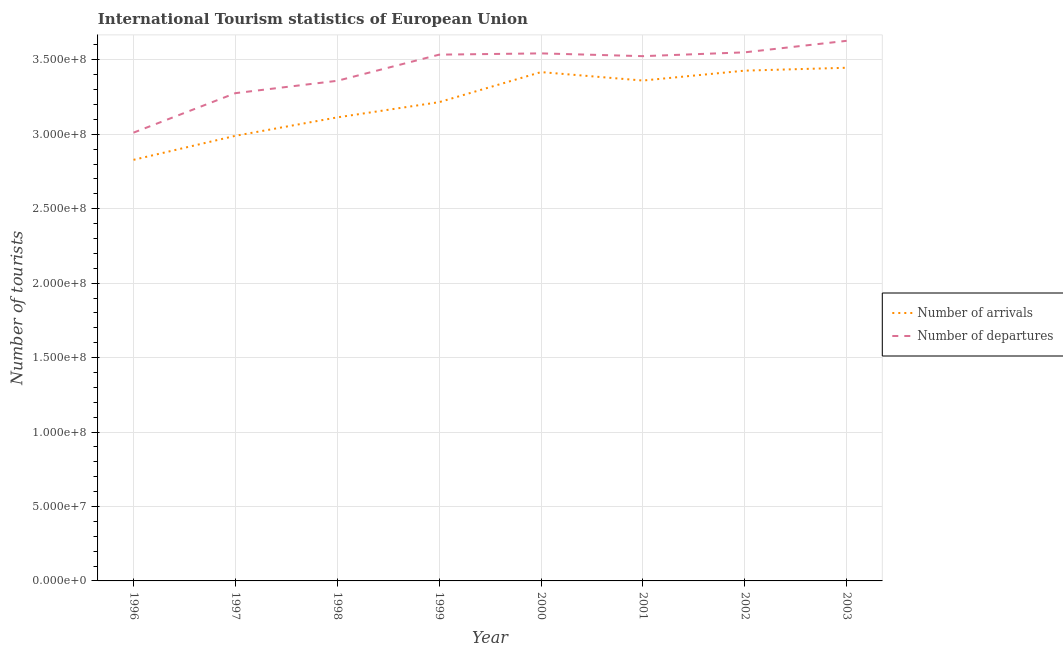Is the number of lines equal to the number of legend labels?
Give a very brief answer. Yes. What is the number of tourist arrivals in 2003?
Provide a succinct answer. 3.45e+08. Across all years, what is the maximum number of tourist departures?
Give a very brief answer. 3.63e+08. Across all years, what is the minimum number of tourist departures?
Provide a short and direct response. 3.01e+08. What is the total number of tourist departures in the graph?
Keep it short and to the point. 2.74e+09. What is the difference between the number of tourist arrivals in 1998 and that in 2000?
Offer a very short reply. -3.04e+07. What is the difference between the number of tourist arrivals in 1997 and the number of tourist departures in 2001?
Make the answer very short. -5.35e+07. What is the average number of tourist arrivals per year?
Provide a short and direct response. 3.22e+08. In the year 1996, what is the difference between the number of tourist departures and number of tourist arrivals?
Make the answer very short. 1.83e+07. In how many years, is the number of tourist arrivals greater than 230000000?
Your response must be concise. 8. What is the ratio of the number of tourist arrivals in 1998 to that in 2003?
Your answer should be very brief. 0.9. What is the difference between the highest and the second highest number of tourist arrivals?
Keep it short and to the point. 1.93e+06. What is the difference between the highest and the lowest number of tourist departures?
Your response must be concise. 6.17e+07. In how many years, is the number of tourist arrivals greater than the average number of tourist arrivals taken over all years?
Your answer should be compact. 4. Does the number of tourist arrivals monotonically increase over the years?
Keep it short and to the point. No. Is the number of tourist departures strictly less than the number of tourist arrivals over the years?
Keep it short and to the point. No. Does the graph contain any zero values?
Provide a short and direct response. No. Does the graph contain grids?
Give a very brief answer. Yes. What is the title of the graph?
Offer a terse response. International Tourism statistics of European Union. What is the label or title of the X-axis?
Your answer should be very brief. Year. What is the label or title of the Y-axis?
Give a very brief answer. Number of tourists. What is the Number of tourists in Number of arrivals in 1996?
Make the answer very short. 2.83e+08. What is the Number of tourists in Number of departures in 1996?
Your response must be concise. 3.01e+08. What is the Number of tourists in Number of arrivals in 1997?
Ensure brevity in your answer.  2.99e+08. What is the Number of tourists of Number of departures in 1997?
Provide a short and direct response. 3.28e+08. What is the Number of tourists in Number of arrivals in 1998?
Your response must be concise. 3.11e+08. What is the Number of tourists in Number of departures in 1998?
Keep it short and to the point. 3.36e+08. What is the Number of tourists of Number of arrivals in 1999?
Provide a short and direct response. 3.22e+08. What is the Number of tourists of Number of departures in 1999?
Keep it short and to the point. 3.53e+08. What is the Number of tourists of Number of arrivals in 2000?
Offer a very short reply. 3.42e+08. What is the Number of tourists in Number of departures in 2000?
Provide a succinct answer. 3.54e+08. What is the Number of tourists in Number of arrivals in 2001?
Ensure brevity in your answer.  3.36e+08. What is the Number of tourists of Number of departures in 2001?
Provide a short and direct response. 3.52e+08. What is the Number of tourists in Number of arrivals in 2002?
Make the answer very short. 3.43e+08. What is the Number of tourists in Number of departures in 2002?
Ensure brevity in your answer.  3.55e+08. What is the Number of tourists of Number of arrivals in 2003?
Make the answer very short. 3.45e+08. What is the Number of tourists of Number of departures in 2003?
Provide a short and direct response. 3.63e+08. Across all years, what is the maximum Number of tourists of Number of arrivals?
Provide a short and direct response. 3.45e+08. Across all years, what is the maximum Number of tourists of Number of departures?
Provide a short and direct response. 3.63e+08. Across all years, what is the minimum Number of tourists of Number of arrivals?
Give a very brief answer. 2.83e+08. Across all years, what is the minimum Number of tourists in Number of departures?
Give a very brief answer. 3.01e+08. What is the total Number of tourists in Number of arrivals in the graph?
Ensure brevity in your answer.  2.58e+09. What is the total Number of tourists in Number of departures in the graph?
Offer a very short reply. 2.74e+09. What is the difference between the Number of tourists in Number of arrivals in 1996 and that in 1997?
Offer a terse response. -1.61e+07. What is the difference between the Number of tourists of Number of departures in 1996 and that in 1997?
Offer a terse response. -2.65e+07. What is the difference between the Number of tourists in Number of arrivals in 1996 and that in 1998?
Provide a succinct answer. -2.85e+07. What is the difference between the Number of tourists of Number of departures in 1996 and that in 1998?
Offer a terse response. -3.48e+07. What is the difference between the Number of tourists in Number of arrivals in 1996 and that in 1999?
Offer a very short reply. -3.87e+07. What is the difference between the Number of tourists in Number of departures in 1996 and that in 1999?
Keep it short and to the point. -5.24e+07. What is the difference between the Number of tourists in Number of arrivals in 1996 and that in 2000?
Make the answer very short. -5.89e+07. What is the difference between the Number of tourists of Number of departures in 1996 and that in 2000?
Your response must be concise. -5.32e+07. What is the difference between the Number of tourists of Number of arrivals in 1996 and that in 2001?
Provide a short and direct response. -5.32e+07. What is the difference between the Number of tourists in Number of departures in 1996 and that in 2001?
Your answer should be very brief. -5.14e+07. What is the difference between the Number of tourists in Number of arrivals in 1996 and that in 2002?
Provide a succinct answer. -5.99e+07. What is the difference between the Number of tourists of Number of departures in 1996 and that in 2002?
Your response must be concise. -5.39e+07. What is the difference between the Number of tourists of Number of arrivals in 1996 and that in 2003?
Make the answer very short. -6.18e+07. What is the difference between the Number of tourists in Number of departures in 1996 and that in 2003?
Your answer should be compact. -6.17e+07. What is the difference between the Number of tourists of Number of arrivals in 1997 and that in 1998?
Make the answer very short. -1.24e+07. What is the difference between the Number of tourists of Number of departures in 1997 and that in 1998?
Your answer should be very brief. -8.30e+06. What is the difference between the Number of tourists of Number of arrivals in 1997 and that in 1999?
Offer a terse response. -2.26e+07. What is the difference between the Number of tourists in Number of departures in 1997 and that in 1999?
Your answer should be very brief. -2.59e+07. What is the difference between the Number of tourists of Number of arrivals in 1997 and that in 2000?
Ensure brevity in your answer.  -4.28e+07. What is the difference between the Number of tourists in Number of departures in 1997 and that in 2000?
Offer a very short reply. -2.67e+07. What is the difference between the Number of tourists in Number of arrivals in 1997 and that in 2001?
Your answer should be compact. -3.71e+07. What is the difference between the Number of tourists of Number of departures in 1997 and that in 2001?
Your response must be concise. -2.49e+07. What is the difference between the Number of tourists of Number of arrivals in 1997 and that in 2002?
Your response must be concise. -4.38e+07. What is the difference between the Number of tourists of Number of departures in 1997 and that in 2002?
Your response must be concise. -2.74e+07. What is the difference between the Number of tourists of Number of arrivals in 1997 and that in 2003?
Make the answer very short. -4.57e+07. What is the difference between the Number of tourists of Number of departures in 1997 and that in 2003?
Your answer should be compact. -3.51e+07. What is the difference between the Number of tourists in Number of arrivals in 1998 and that in 1999?
Offer a terse response. -1.02e+07. What is the difference between the Number of tourists of Number of departures in 1998 and that in 1999?
Your answer should be very brief. -1.76e+07. What is the difference between the Number of tourists of Number of arrivals in 1998 and that in 2000?
Provide a short and direct response. -3.04e+07. What is the difference between the Number of tourists in Number of departures in 1998 and that in 2000?
Offer a terse response. -1.84e+07. What is the difference between the Number of tourists of Number of arrivals in 1998 and that in 2001?
Ensure brevity in your answer.  -2.47e+07. What is the difference between the Number of tourists in Number of departures in 1998 and that in 2001?
Offer a very short reply. -1.66e+07. What is the difference between the Number of tourists of Number of arrivals in 1998 and that in 2002?
Give a very brief answer. -3.14e+07. What is the difference between the Number of tourists in Number of departures in 1998 and that in 2002?
Give a very brief answer. -1.91e+07. What is the difference between the Number of tourists of Number of arrivals in 1998 and that in 2003?
Give a very brief answer. -3.33e+07. What is the difference between the Number of tourists in Number of departures in 1998 and that in 2003?
Offer a terse response. -2.68e+07. What is the difference between the Number of tourists of Number of arrivals in 1999 and that in 2000?
Offer a very short reply. -2.02e+07. What is the difference between the Number of tourists in Number of departures in 1999 and that in 2000?
Your response must be concise. -8.54e+05. What is the difference between the Number of tourists of Number of arrivals in 1999 and that in 2001?
Your response must be concise. -1.45e+07. What is the difference between the Number of tourists in Number of departures in 1999 and that in 2001?
Your answer should be very brief. 1.01e+06. What is the difference between the Number of tourists in Number of arrivals in 1999 and that in 2002?
Provide a short and direct response. -2.12e+07. What is the difference between the Number of tourists in Number of departures in 1999 and that in 2002?
Make the answer very short. -1.55e+06. What is the difference between the Number of tourists in Number of arrivals in 1999 and that in 2003?
Your answer should be very brief. -2.31e+07. What is the difference between the Number of tourists of Number of departures in 1999 and that in 2003?
Your answer should be very brief. -9.29e+06. What is the difference between the Number of tourists in Number of arrivals in 2000 and that in 2001?
Make the answer very short. 5.67e+06. What is the difference between the Number of tourists of Number of departures in 2000 and that in 2001?
Ensure brevity in your answer.  1.86e+06. What is the difference between the Number of tourists in Number of arrivals in 2000 and that in 2002?
Keep it short and to the point. -9.82e+05. What is the difference between the Number of tourists in Number of departures in 2000 and that in 2002?
Offer a very short reply. -7.01e+05. What is the difference between the Number of tourists in Number of arrivals in 2000 and that in 2003?
Your response must be concise. -2.91e+06. What is the difference between the Number of tourists of Number of departures in 2000 and that in 2003?
Ensure brevity in your answer.  -8.43e+06. What is the difference between the Number of tourists in Number of arrivals in 2001 and that in 2002?
Provide a short and direct response. -6.65e+06. What is the difference between the Number of tourists of Number of departures in 2001 and that in 2002?
Your response must be concise. -2.56e+06. What is the difference between the Number of tourists in Number of arrivals in 2001 and that in 2003?
Your answer should be very brief. -8.59e+06. What is the difference between the Number of tourists of Number of departures in 2001 and that in 2003?
Your response must be concise. -1.03e+07. What is the difference between the Number of tourists of Number of arrivals in 2002 and that in 2003?
Your response must be concise. -1.93e+06. What is the difference between the Number of tourists in Number of departures in 2002 and that in 2003?
Your response must be concise. -7.73e+06. What is the difference between the Number of tourists in Number of arrivals in 1996 and the Number of tourists in Number of departures in 1997?
Ensure brevity in your answer.  -4.48e+07. What is the difference between the Number of tourists of Number of arrivals in 1996 and the Number of tourists of Number of departures in 1998?
Ensure brevity in your answer.  -5.31e+07. What is the difference between the Number of tourists of Number of arrivals in 1996 and the Number of tourists of Number of departures in 1999?
Provide a short and direct response. -7.06e+07. What is the difference between the Number of tourists in Number of arrivals in 1996 and the Number of tourists in Number of departures in 2000?
Provide a short and direct response. -7.15e+07. What is the difference between the Number of tourists of Number of arrivals in 1996 and the Number of tourists of Number of departures in 2001?
Offer a terse response. -6.96e+07. What is the difference between the Number of tourists in Number of arrivals in 1996 and the Number of tourists in Number of departures in 2002?
Provide a short and direct response. -7.22e+07. What is the difference between the Number of tourists in Number of arrivals in 1996 and the Number of tourists in Number of departures in 2003?
Ensure brevity in your answer.  -7.99e+07. What is the difference between the Number of tourists of Number of arrivals in 1997 and the Number of tourists of Number of departures in 1998?
Ensure brevity in your answer.  -3.69e+07. What is the difference between the Number of tourists in Number of arrivals in 1997 and the Number of tourists in Number of departures in 1999?
Provide a short and direct response. -5.45e+07. What is the difference between the Number of tourists of Number of arrivals in 1997 and the Number of tourists of Number of departures in 2000?
Ensure brevity in your answer.  -5.54e+07. What is the difference between the Number of tourists of Number of arrivals in 1997 and the Number of tourists of Number of departures in 2001?
Make the answer very short. -5.35e+07. What is the difference between the Number of tourists of Number of arrivals in 1997 and the Number of tourists of Number of departures in 2002?
Offer a terse response. -5.61e+07. What is the difference between the Number of tourists of Number of arrivals in 1997 and the Number of tourists of Number of departures in 2003?
Keep it short and to the point. -6.38e+07. What is the difference between the Number of tourists of Number of arrivals in 1998 and the Number of tourists of Number of departures in 1999?
Provide a succinct answer. -4.21e+07. What is the difference between the Number of tourists in Number of arrivals in 1998 and the Number of tourists in Number of departures in 2000?
Provide a succinct answer. -4.30e+07. What is the difference between the Number of tourists in Number of arrivals in 1998 and the Number of tourists in Number of departures in 2001?
Your answer should be very brief. -4.11e+07. What is the difference between the Number of tourists of Number of arrivals in 1998 and the Number of tourists of Number of departures in 2002?
Your response must be concise. -4.37e+07. What is the difference between the Number of tourists in Number of arrivals in 1998 and the Number of tourists in Number of departures in 2003?
Provide a succinct answer. -5.14e+07. What is the difference between the Number of tourists of Number of arrivals in 1999 and the Number of tourists of Number of departures in 2000?
Your response must be concise. -3.28e+07. What is the difference between the Number of tourists in Number of arrivals in 1999 and the Number of tourists in Number of departures in 2001?
Your answer should be compact. -3.09e+07. What is the difference between the Number of tourists in Number of arrivals in 1999 and the Number of tourists in Number of departures in 2002?
Make the answer very short. -3.35e+07. What is the difference between the Number of tourists in Number of arrivals in 1999 and the Number of tourists in Number of departures in 2003?
Make the answer very short. -4.12e+07. What is the difference between the Number of tourists of Number of arrivals in 2000 and the Number of tourists of Number of departures in 2001?
Make the answer very short. -1.07e+07. What is the difference between the Number of tourists in Number of arrivals in 2000 and the Number of tourists in Number of departures in 2002?
Provide a succinct answer. -1.33e+07. What is the difference between the Number of tourists of Number of arrivals in 2000 and the Number of tourists of Number of departures in 2003?
Make the answer very short. -2.10e+07. What is the difference between the Number of tourists of Number of arrivals in 2001 and the Number of tourists of Number of departures in 2002?
Provide a succinct answer. -1.89e+07. What is the difference between the Number of tourists of Number of arrivals in 2001 and the Number of tourists of Number of departures in 2003?
Ensure brevity in your answer.  -2.67e+07. What is the difference between the Number of tourists in Number of arrivals in 2002 and the Number of tourists in Number of departures in 2003?
Your response must be concise. -2.00e+07. What is the average Number of tourists of Number of arrivals per year?
Provide a short and direct response. 3.22e+08. What is the average Number of tourists in Number of departures per year?
Make the answer very short. 3.43e+08. In the year 1996, what is the difference between the Number of tourists of Number of arrivals and Number of tourists of Number of departures?
Your answer should be very brief. -1.83e+07. In the year 1997, what is the difference between the Number of tourists of Number of arrivals and Number of tourists of Number of departures?
Offer a terse response. -2.86e+07. In the year 1998, what is the difference between the Number of tourists in Number of arrivals and Number of tourists in Number of departures?
Your response must be concise. -2.46e+07. In the year 1999, what is the difference between the Number of tourists in Number of arrivals and Number of tourists in Number of departures?
Your answer should be very brief. -3.19e+07. In the year 2000, what is the difference between the Number of tourists in Number of arrivals and Number of tourists in Number of departures?
Offer a terse response. -1.26e+07. In the year 2001, what is the difference between the Number of tourists in Number of arrivals and Number of tourists in Number of departures?
Your answer should be compact. -1.64e+07. In the year 2002, what is the difference between the Number of tourists in Number of arrivals and Number of tourists in Number of departures?
Offer a very short reply. -1.23e+07. In the year 2003, what is the difference between the Number of tourists in Number of arrivals and Number of tourists in Number of departures?
Your response must be concise. -1.81e+07. What is the ratio of the Number of tourists in Number of arrivals in 1996 to that in 1997?
Make the answer very short. 0.95. What is the ratio of the Number of tourists of Number of departures in 1996 to that in 1997?
Ensure brevity in your answer.  0.92. What is the ratio of the Number of tourists in Number of arrivals in 1996 to that in 1998?
Your answer should be very brief. 0.91. What is the ratio of the Number of tourists in Number of departures in 1996 to that in 1998?
Provide a short and direct response. 0.9. What is the ratio of the Number of tourists of Number of arrivals in 1996 to that in 1999?
Your answer should be very brief. 0.88. What is the ratio of the Number of tourists of Number of departures in 1996 to that in 1999?
Make the answer very short. 0.85. What is the ratio of the Number of tourists of Number of arrivals in 1996 to that in 2000?
Offer a very short reply. 0.83. What is the ratio of the Number of tourists in Number of departures in 1996 to that in 2000?
Provide a succinct answer. 0.85. What is the ratio of the Number of tourists in Number of arrivals in 1996 to that in 2001?
Ensure brevity in your answer.  0.84. What is the ratio of the Number of tourists in Number of departures in 1996 to that in 2001?
Your answer should be very brief. 0.85. What is the ratio of the Number of tourists in Number of arrivals in 1996 to that in 2002?
Give a very brief answer. 0.83. What is the ratio of the Number of tourists in Number of departures in 1996 to that in 2002?
Make the answer very short. 0.85. What is the ratio of the Number of tourists in Number of arrivals in 1996 to that in 2003?
Your response must be concise. 0.82. What is the ratio of the Number of tourists in Number of departures in 1996 to that in 2003?
Offer a very short reply. 0.83. What is the ratio of the Number of tourists in Number of arrivals in 1997 to that in 1998?
Make the answer very short. 0.96. What is the ratio of the Number of tourists in Number of departures in 1997 to that in 1998?
Offer a very short reply. 0.98. What is the ratio of the Number of tourists in Number of arrivals in 1997 to that in 1999?
Your answer should be compact. 0.93. What is the ratio of the Number of tourists in Number of departures in 1997 to that in 1999?
Keep it short and to the point. 0.93. What is the ratio of the Number of tourists in Number of arrivals in 1997 to that in 2000?
Your answer should be compact. 0.87. What is the ratio of the Number of tourists of Number of departures in 1997 to that in 2000?
Keep it short and to the point. 0.92. What is the ratio of the Number of tourists of Number of arrivals in 1997 to that in 2001?
Keep it short and to the point. 0.89. What is the ratio of the Number of tourists in Number of departures in 1997 to that in 2001?
Provide a short and direct response. 0.93. What is the ratio of the Number of tourists of Number of arrivals in 1997 to that in 2002?
Your answer should be compact. 0.87. What is the ratio of the Number of tourists of Number of departures in 1997 to that in 2002?
Provide a succinct answer. 0.92. What is the ratio of the Number of tourists in Number of arrivals in 1997 to that in 2003?
Your response must be concise. 0.87. What is the ratio of the Number of tourists in Number of departures in 1997 to that in 2003?
Your response must be concise. 0.9. What is the ratio of the Number of tourists in Number of arrivals in 1998 to that in 1999?
Ensure brevity in your answer.  0.97. What is the ratio of the Number of tourists of Number of departures in 1998 to that in 1999?
Your response must be concise. 0.95. What is the ratio of the Number of tourists of Number of arrivals in 1998 to that in 2000?
Keep it short and to the point. 0.91. What is the ratio of the Number of tourists of Number of departures in 1998 to that in 2000?
Keep it short and to the point. 0.95. What is the ratio of the Number of tourists of Number of arrivals in 1998 to that in 2001?
Your answer should be compact. 0.93. What is the ratio of the Number of tourists of Number of departures in 1998 to that in 2001?
Offer a terse response. 0.95. What is the ratio of the Number of tourists in Number of arrivals in 1998 to that in 2002?
Offer a very short reply. 0.91. What is the ratio of the Number of tourists of Number of departures in 1998 to that in 2002?
Your answer should be very brief. 0.95. What is the ratio of the Number of tourists in Number of arrivals in 1998 to that in 2003?
Offer a very short reply. 0.9. What is the ratio of the Number of tourists in Number of departures in 1998 to that in 2003?
Keep it short and to the point. 0.93. What is the ratio of the Number of tourists in Number of arrivals in 1999 to that in 2000?
Offer a very short reply. 0.94. What is the ratio of the Number of tourists of Number of arrivals in 1999 to that in 2001?
Your answer should be compact. 0.96. What is the ratio of the Number of tourists in Number of departures in 1999 to that in 2001?
Provide a succinct answer. 1. What is the ratio of the Number of tourists in Number of arrivals in 1999 to that in 2002?
Provide a succinct answer. 0.94. What is the ratio of the Number of tourists of Number of departures in 1999 to that in 2002?
Keep it short and to the point. 1. What is the ratio of the Number of tourists in Number of arrivals in 1999 to that in 2003?
Offer a very short reply. 0.93. What is the ratio of the Number of tourists in Number of departures in 1999 to that in 2003?
Your response must be concise. 0.97. What is the ratio of the Number of tourists of Number of arrivals in 2000 to that in 2001?
Provide a short and direct response. 1.02. What is the ratio of the Number of tourists in Number of departures in 2000 to that in 2002?
Give a very brief answer. 1. What is the ratio of the Number of tourists in Number of departures in 2000 to that in 2003?
Your answer should be compact. 0.98. What is the ratio of the Number of tourists of Number of arrivals in 2001 to that in 2002?
Offer a very short reply. 0.98. What is the ratio of the Number of tourists in Number of arrivals in 2001 to that in 2003?
Give a very brief answer. 0.98. What is the ratio of the Number of tourists of Number of departures in 2001 to that in 2003?
Offer a terse response. 0.97. What is the ratio of the Number of tourists in Number of arrivals in 2002 to that in 2003?
Make the answer very short. 0.99. What is the ratio of the Number of tourists in Number of departures in 2002 to that in 2003?
Keep it short and to the point. 0.98. What is the difference between the highest and the second highest Number of tourists in Number of arrivals?
Your answer should be very brief. 1.93e+06. What is the difference between the highest and the second highest Number of tourists in Number of departures?
Give a very brief answer. 7.73e+06. What is the difference between the highest and the lowest Number of tourists of Number of arrivals?
Provide a short and direct response. 6.18e+07. What is the difference between the highest and the lowest Number of tourists in Number of departures?
Offer a very short reply. 6.17e+07. 